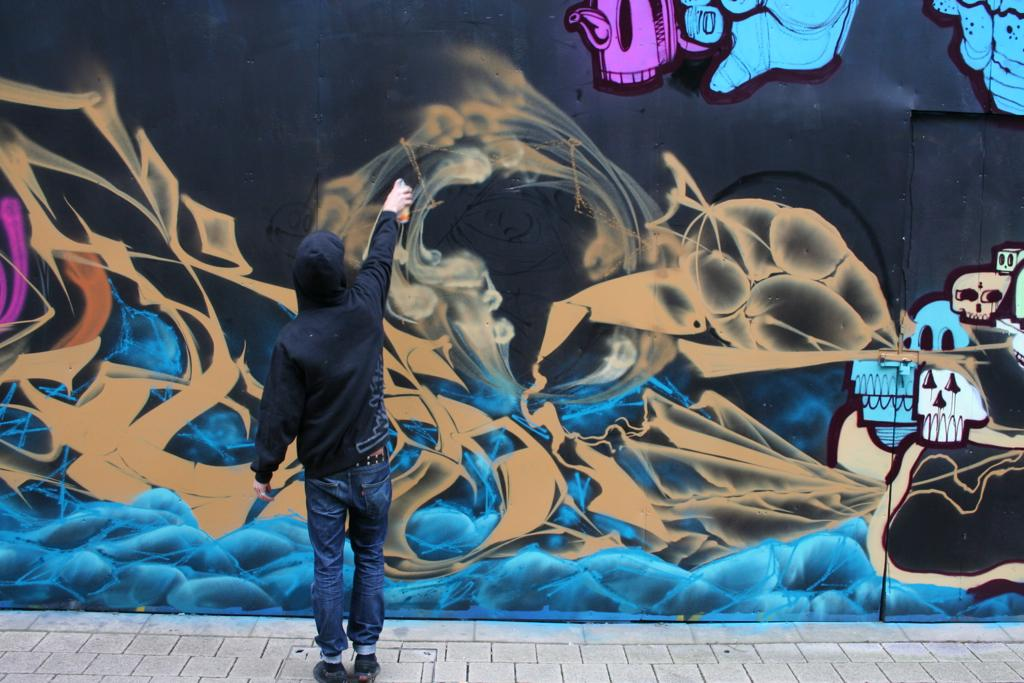What can be seen in the image? There is a person in the image. What is the person wearing? The person is wearing jeans. Where is the person standing? The person is standing on a footpath. What is the person holding? The person is holding an object. What is present on the wall in the image? There is a painting on the wall. What direction is the owner of the painting facing in the image? There is no information about the painting's owner in the image, and therefore we cannot determine the direction they are facing. 